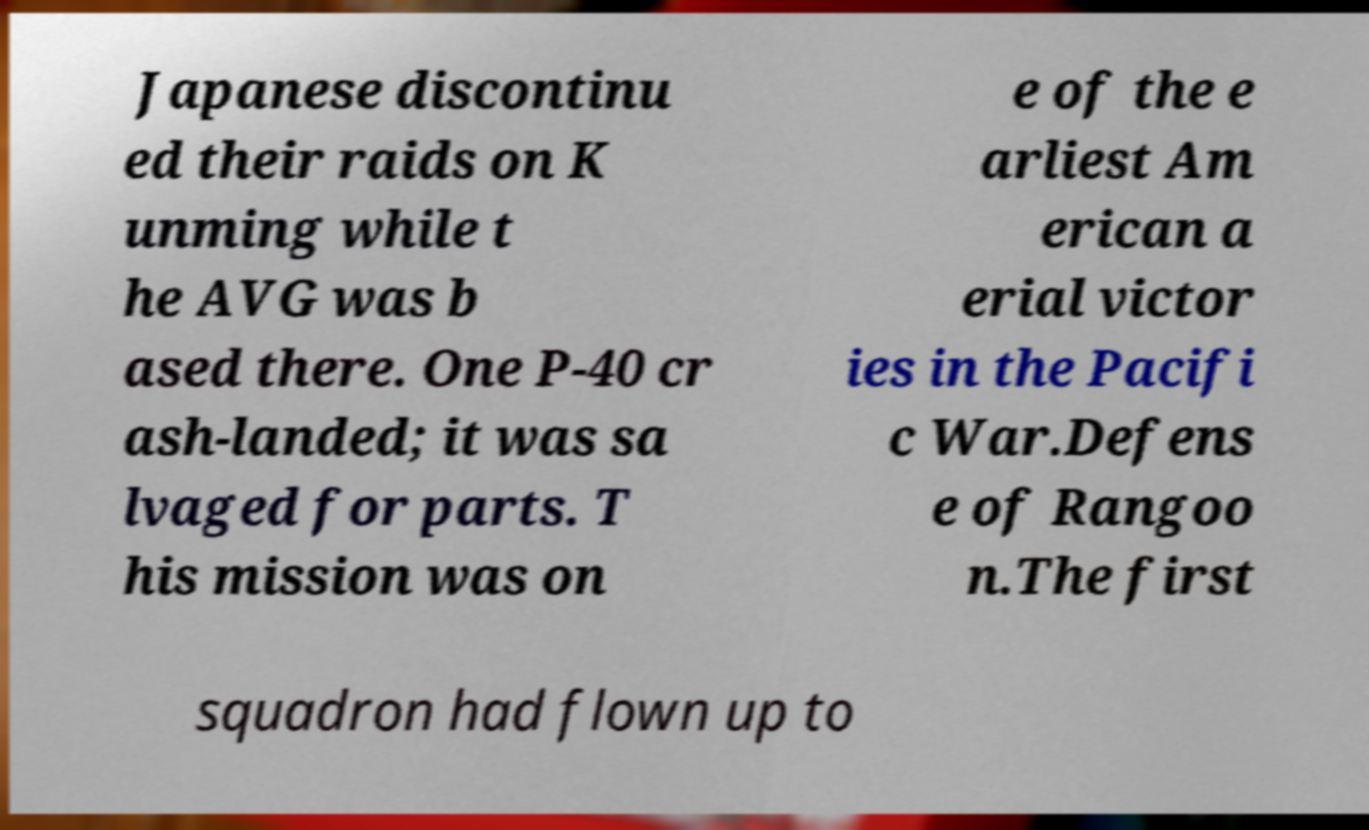I need the written content from this picture converted into text. Can you do that? Japanese discontinu ed their raids on K unming while t he AVG was b ased there. One P-40 cr ash-landed; it was sa lvaged for parts. T his mission was on e of the e arliest Am erican a erial victor ies in the Pacifi c War.Defens e of Rangoo n.The first squadron had flown up to 